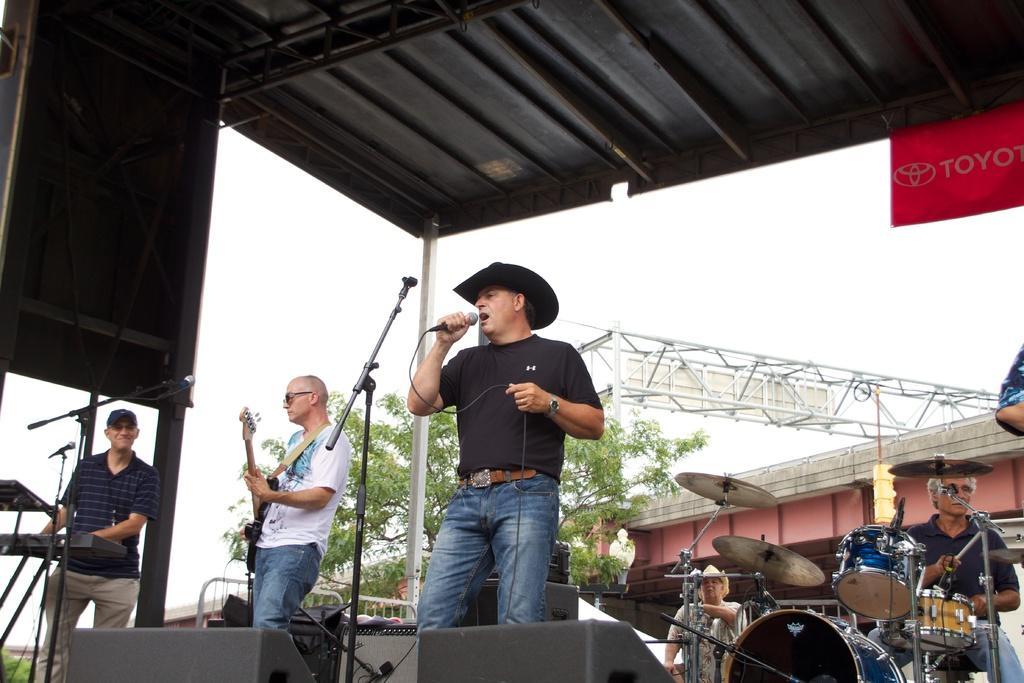Describe this image in one or two sentences. In this picture we can see sky is cloudy, and here is the trees ,a person standing on the stage he is singing and he is holding a microphone in his hand ,and left to opposite a man is standing and playing a guitar, and left to opposite a man is standing and playing a piano ,and right to back a person is sitting and playing musical drums. 